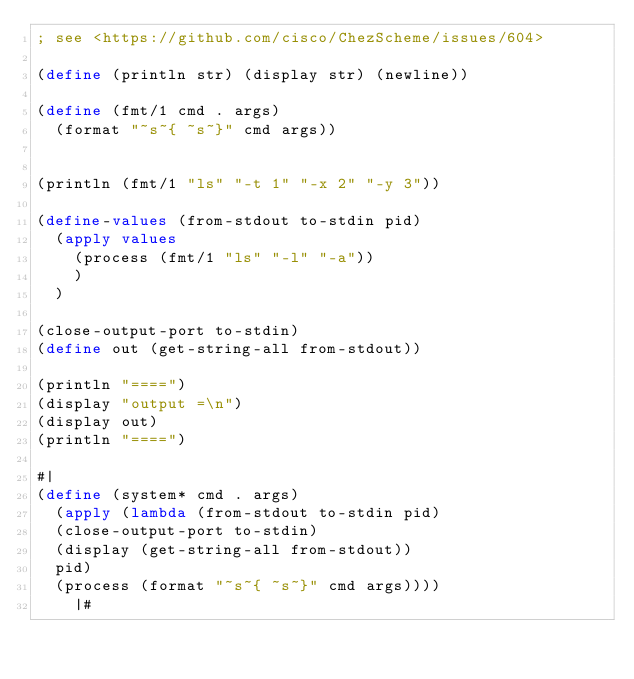<code> <loc_0><loc_0><loc_500><loc_500><_Scheme_>; see <https://github.com/cisco/ChezScheme/issues/604>

(define (println str) (display str) (newline))

(define (fmt/1 cmd . args)
  (format "~s~{ ~s~}" cmd args))


(println (fmt/1 "ls" "-t 1" "-x 2" "-y 3"))

(define-values (from-stdout to-stdin pid)
  (apply values 
    (process (fmt/1 "ls" "-l" "-a"))
    )
  )

(close-output-port to-stdin)
(define out (get-string-all from-stdout))

(println "====")
(display "output =\n")
(display out)
(println "====")

#|
(define (system* cmd . args)
  (apply (lambda (from-stdout to-stdin pid)
  (close-output-port to-stdin)
  (display (get-string-all from-stdout))
  pid)
  (process (format "~s~{ ~s~}" cmd args))))
    |#
    </code> 